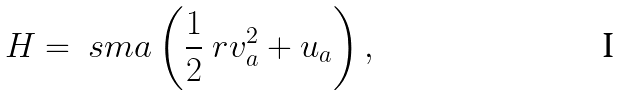Convert formula to latex. <formula><loc_0><loc_0><loc_500><loc_500>H = \ s m a \left ( \frac { 1 } { 2 } \ r v _ { a } ^ { 2 } + u _ { a } \right ) ,</formula> 